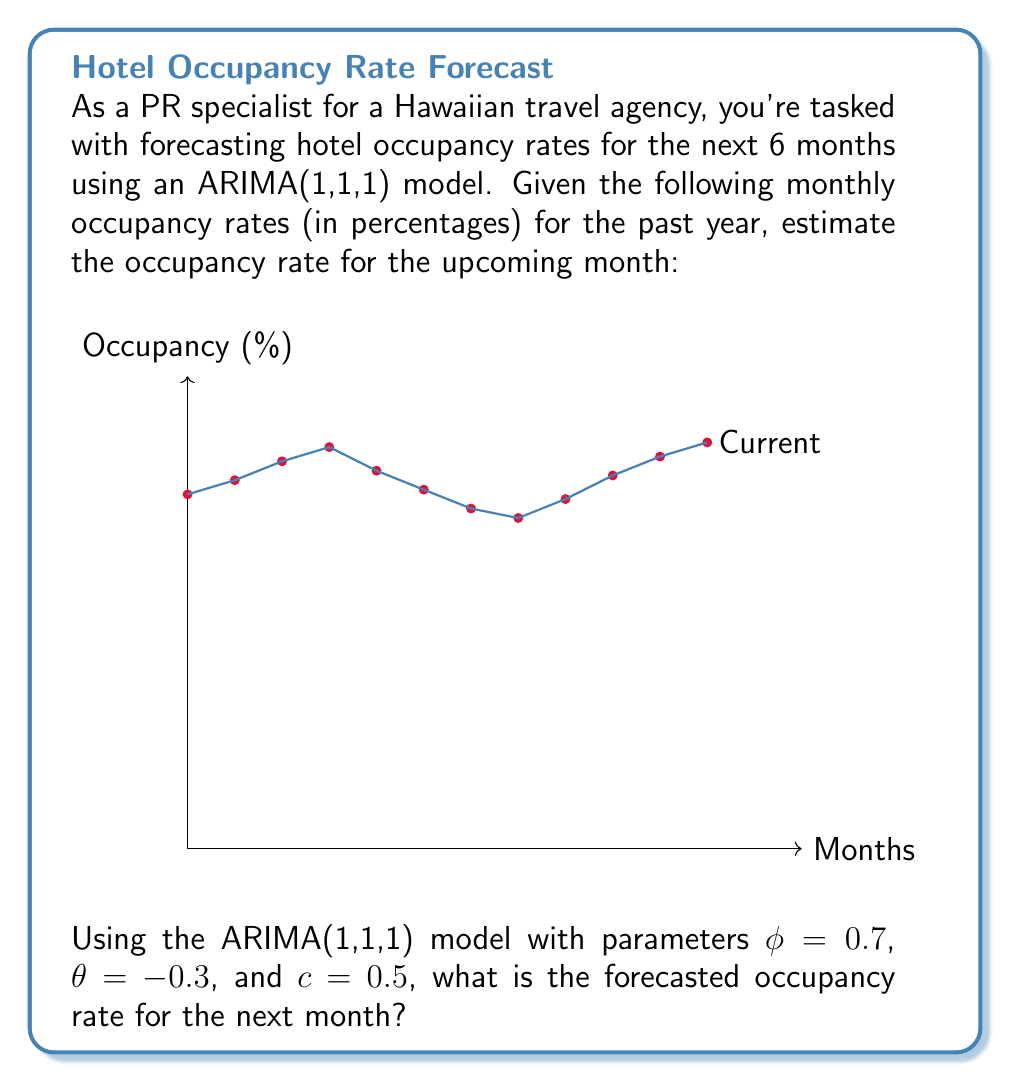Show me your answer to this math problem. To forecast using an ARIMA(1,1,1) model, we follow these steps:

1) The ARIMA(1,1,1) model is given by:
   $$(1-\phi B)(1-B)y_t = c + (1+\theta B)\epsilon_t$$
   where $B$ is the backshift operator.

2) For forecasting one step ahead, we use:
   $$\hat{y}_{t+1} = y_t + \phi(y_t - y_{t-1}) + c + \theta\epsilon_t$$

3) We need to calculate $\epsilon_t$:
   $$\epsilon_t = y_t - \hat{y}_t = y_t - (y_{t-1} + \phi(y_{t-1} - y_{t-2}) + c + \theta\epsilon_{t-1})$$

4) Using the given data:
   $y_t = 86$, $y_{t-1} = 83$, $y_{t-2} = 79$

5) We first need to estimate $\epsilon_{t-1}$:
   $$\epsilon_{t-1} = 83 - (79 + 0.7(79 - 74) + 0.5 + (-0.3)\epsilon_{t-2})$$
   Assuming $\epsilon_{t-2} \approx 0$ for simplicity:
   $$\epsilon_{t-1} \approx 83 - (79 + 0.7(5) + 0.5) = 0$

6) Now we can estimate $\epsilon_t$:
   $$\epsilon_t = 86 - (83 + 0.7(83 - 79) + 0.5 + (-0.3)(0)) = -0.3$$

7) Finally, we can forecast $\hat{y}_{t+1}$:
   $$\hat{y}_{t+1} = 86 + 0.7(86 - 83) + 0.5 + (-0.3)(-0.3)$$
   $$= 86 + 2.1 + 0.5 + 0.09 = 88.69$$

Therefore, the forecasted occupancy rate for the next month is approximately 88.69%.
Answer: 88.69% 